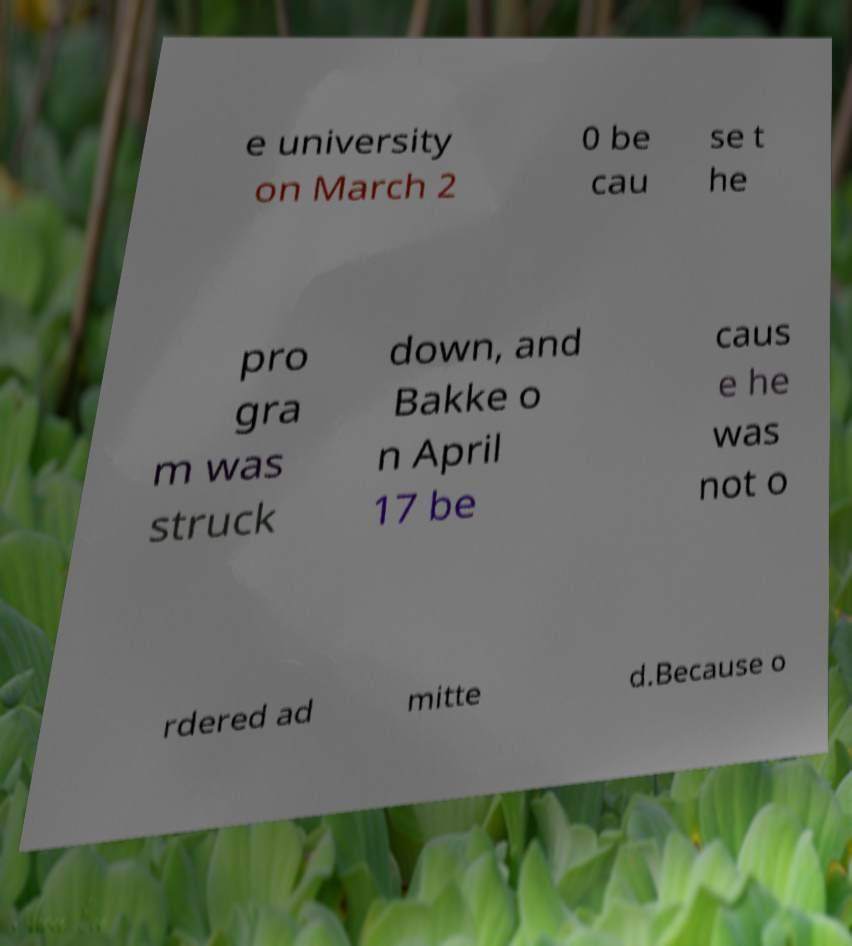What messages or text are displayed in this image? I need them in a readable, typed format. e university on March 2 0 be cau se t he pro gra m was struck down, and Bakke o n April 17 be caus e he was not o rdered ad mitte d.Because o 